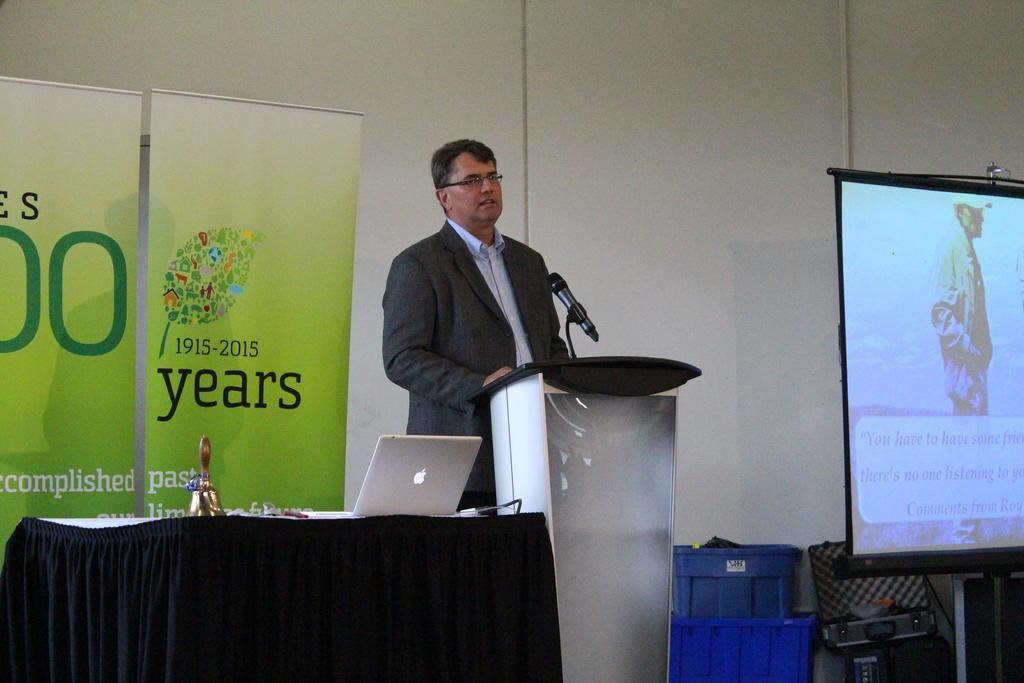Provide a one-sentence caption for the provided image. A banner with the years 1915-2015 displaying next to a speaker. 